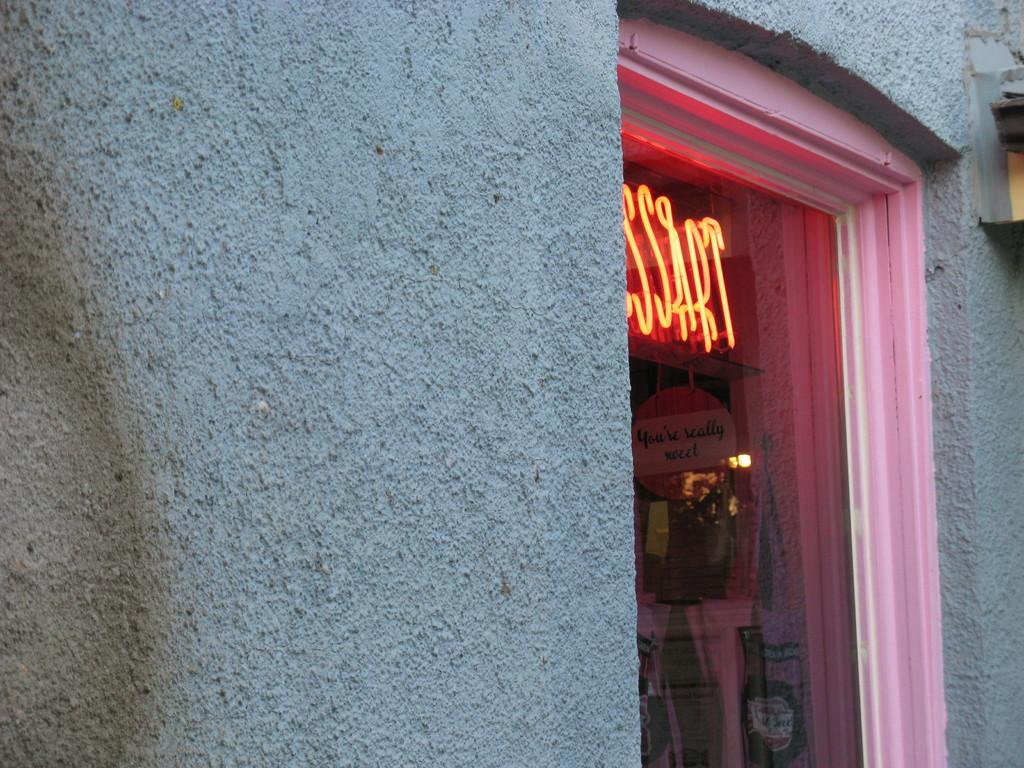What type of structure can be seen in the image? There is a wall in the image. What is the purpose of the glass door in the image? The glass door provides a view of the inside. What can be seen through the glass door? There are various objects, lights, and a board visible through the glass door. Is there a crack visible on the glass door in the image? There is no mention of a crack on the glass door in the provided facts, so we cannot determine its presence from the image. 